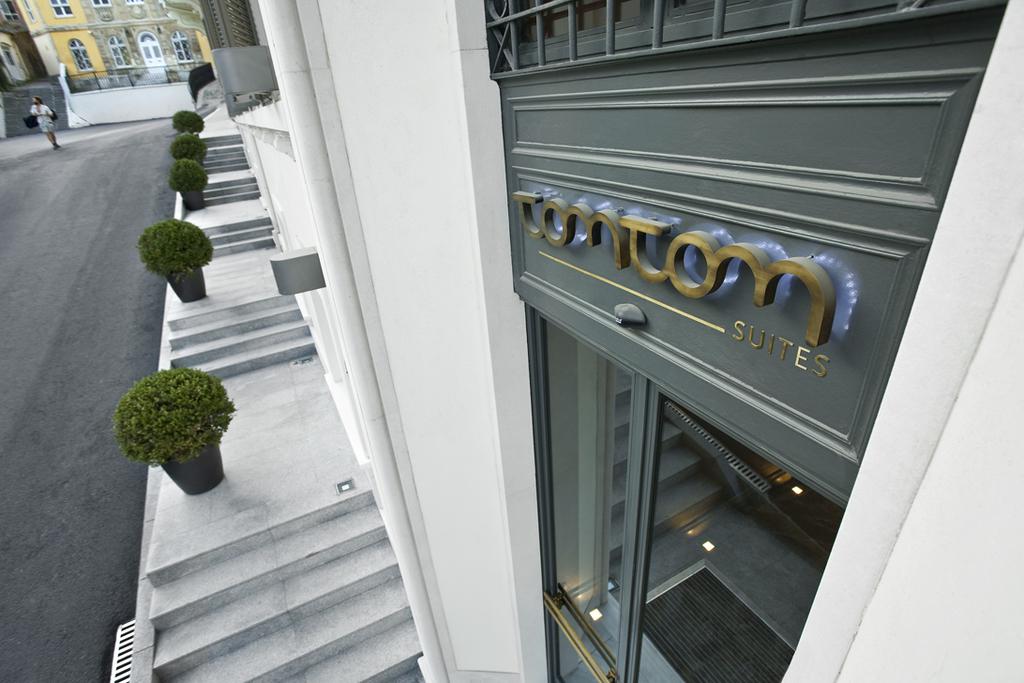What is the name of the hotel building on the right?
Offer a terse response. Tomtom. What is the s word under the logo?
Offer a terse response. Suites. 